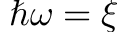Convert formula to latex. <formula><loc_0><loc_0><loc_500><loc_500>\hbar { \omega } = \xi</formula> 